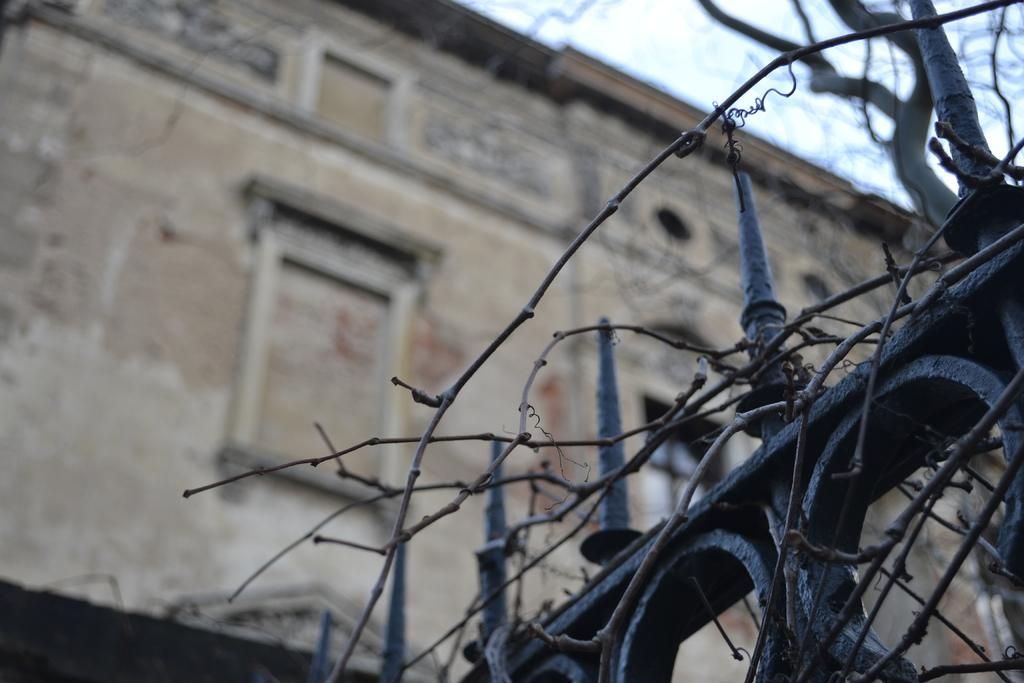What type of gate is visible in the image? There is an iron gate in the image. What is the color of the iron gate? The iron gate is black in color. What is attached to the iron gate? There are dried sticks on the iron gate. What structure can be seen in the image? There is a building in the image. What is visible at the top of the image? The sky is visible at the top of the image. What type of toothpaste is being used to clean the iron gate in the image? There is no toothpaste present in the image, and the iron gate is not being cleaned. 